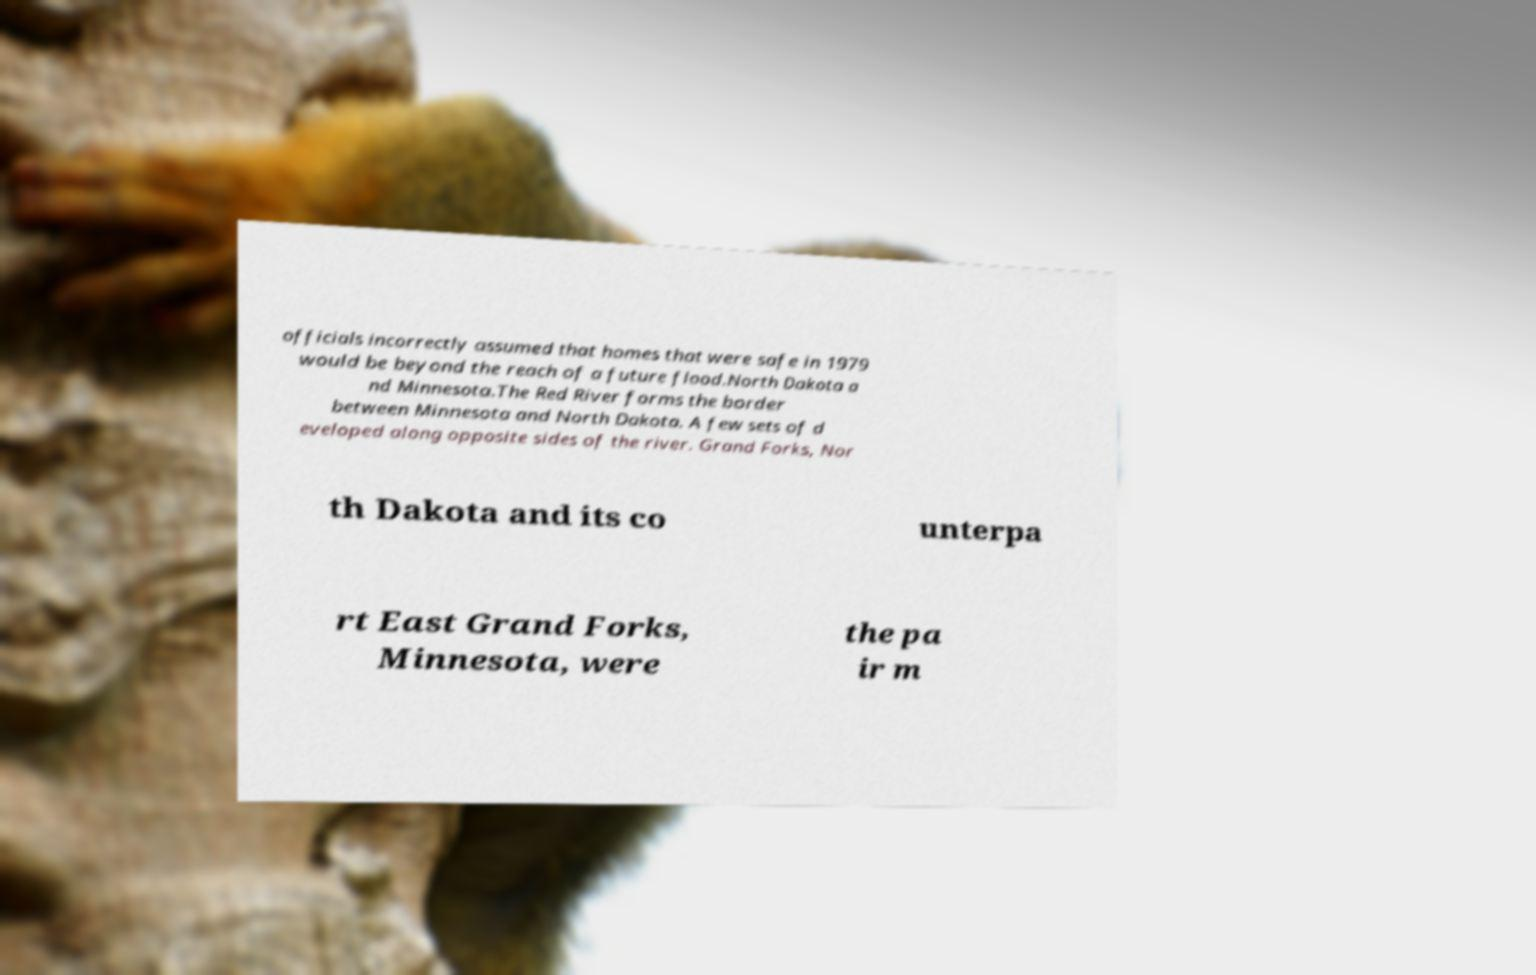Can you accurately transcribe the text from the provided image for me? officials incorrectly assumed that homes that were safe in 1979 would be beyond the reach of a future flood.North Dakota a nd Minnesota.The Red River forms the border between Minnesota and North Dakota. A few sets of d eveloped along opposite sides of the river. Grand Forks, Nor th Dakota and its co unterpa rt East Grand Forks, Minnesota, were the pa ir m 